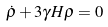Convert formula to latex. <formula><loc_0><loc_0><loc_500><loc_500>\dot { \rho } + 3 \gamma H \rho = 0</formula> 